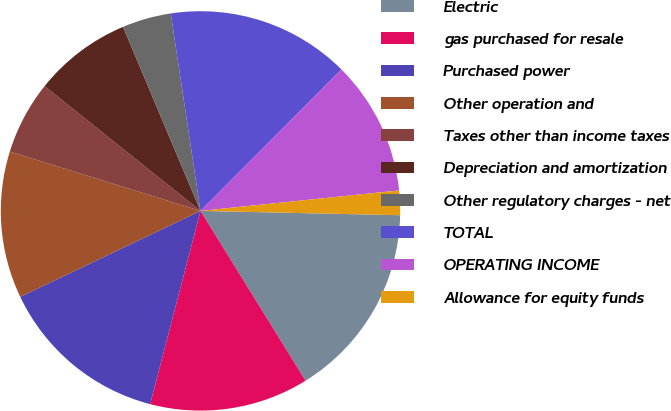Convert chart to OTSL. <chart><loc_0><loc_0><loc_500><loc_500><pie_chart><fcel>Electric<fcel>gas purchased for resale<fcel>Purchased power<fcel>Other operation and<fcel>Taxes other than income taxes<fcel>Depreciation and amortization<fcel>Other regulatory charges - net<fcel>TOTAL<fcel>OPERATING INCOME<fcel>Allowance for equity funds<nl><fcel>15.84%<fcel>12.87%<fcel>13.86%<fcel>11.88%<fcel>5.94%<fcel>7.92%<fcel>3.96%<fcel>14.85%<fcel>10.89%<fcel>1.98%<nl></chart> 